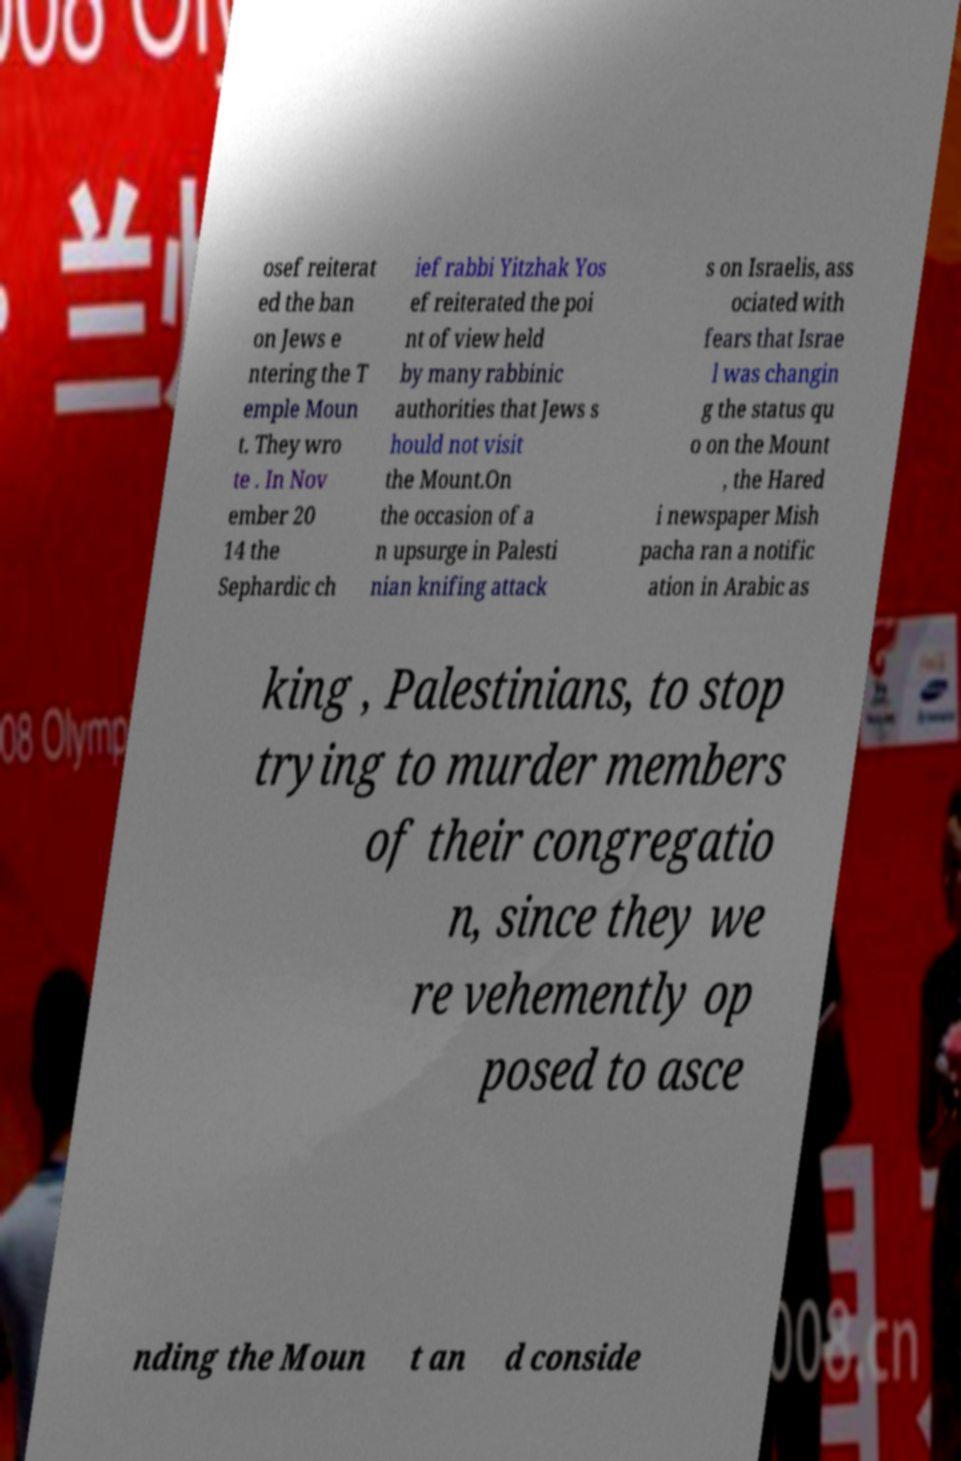I need the written content from this picture converted into text. Can you do that? osef reiterat ed the ban on Jews e ntering the T emple Moun t. They wro te . In Nov ember 20 14 the Sephardic ch ief rabbi Yitzhak Yos ef reiterated the poi nt of view held by many rabbinic authorities that Jews s hould not visit the Mount.On the occasion of a n upsurge in Palesti nian knifing attack s on Israelis, ass ociated with fears that Israe l was changin g the status qu o on the Mount , the Hared i newspaper Mish pacha ran a notific ation in Arabic as king , Palestinians, to stop trying to murder members of their congregatio n, since they we re vehemently op posed to asce nding the Moun t an d conside 